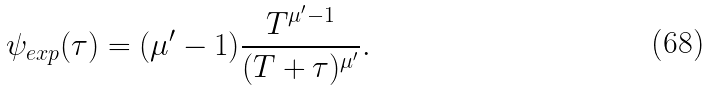Convert formula to latex. <formula><loc_0><loc_0><loc_500><loc_500>\psi _ { e x p } ( \tau ) = ( \mu ^ { \prime } - 1 ) \frac { T ^ { \mu ^ { \prime } - 1 } } { ( T + \tau ) ^ { \mu ^ { \prime } } } .</formula> 